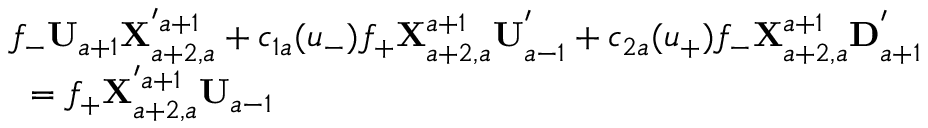<formula> <loc_0><loc_0><loc_500><loc_500>\begin{array} { l } { { f _ { - } { U } _ { a + 1 } { X } _ { a + 2 , a } ^ { ^ { \prime } a + 1 } + c _ { 1 a } ( u _ { - } ) f _ { + } { X } _ { a + 2 , a } ^ { a + 1 } { U } _ { a - 1 } ^ { ^ { \prime } } + c _ { 2 a } ( u _ { + } ) f _ { - } { X } _ { a + 2 , a } ^ { a + 1 } { D } _ { a + 1 } ^ { ^ { \prime } } } } \\ { { = f _ { + } { X } _ { a + 2 , a } ^ { ^ { \prime } a + 1 } { U } _ { a - 1 } } } \end{array}</formula> 